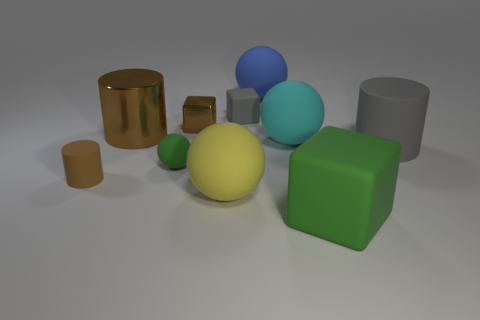Subtract all gray cylinders. How many cylinders are left? 2 Subtract all gray blocks. How many brown cylinders are left? 2 Subtract 1 cylinders. How many cylinders are left? 2 Subtract all green spheres. How many spheres are left? 3 Subtract all cyan blocks. Subtract all cyan cylinders. How many blocks are left? 3 Subtract all cylinders. How many objects are left? 7 Subtract all large green rubber blocks. Subtract all yellow balls. How many objects are left? 8 Add 5 large green things. How many large green things are left? 6 Add 9 blue objects. How many blue objects exist? 10 Subtract 0 purple balls. How many objects are left? 10 